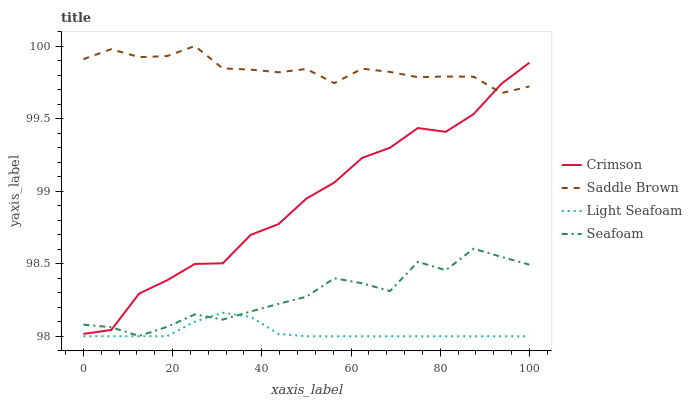Does Light Seafoam have the minimum area under the curve?
Answer yes or no. Yes. Does Saddle Brown have the maximum area under the curve?
Answer yes or no. Yes. Does Saddle Brown have the minimum area under the curve?
Answer yes or no. No. Does Light Seafoam have the maximum area under the curve?
Answer yes or no. No. Is Light Seafoam the smoothest?
Answer yes or no. Yes. Is Crimson the roughest?
Answer yes or no. Yes. Is Saddle Brown the smoothest?
Answer yes or no. No. Is Saddle Brown the roughest?
Answer yes or no. No. Does Light Seafoam have the lowest value?
Answer yes or no. Yes. Does Saddle Brown have the lowest value?
Answer yes or no. No. Does Saddle Brown have the highest value?
Answer yes or no. Yes. Does Light Seafoam have the highest value?
Answer yes or no. No. Is Seafoam less than Saddle Brown?
Answer yes or no. Yes. Is Saddle Brown greater than Seafoam?
Answer yes or no. Yes. Does Seafoam intersect Light Seafoam?
Answer yes or no. Yes. Is Seafoam less than Light Seafoam?
Answer yes or no. No. Is Seafoam greater than Light Seafoam?
Answer yes or no. No. Does Seafoam intersect Saddle Brown?
Answer yes or no. No. 